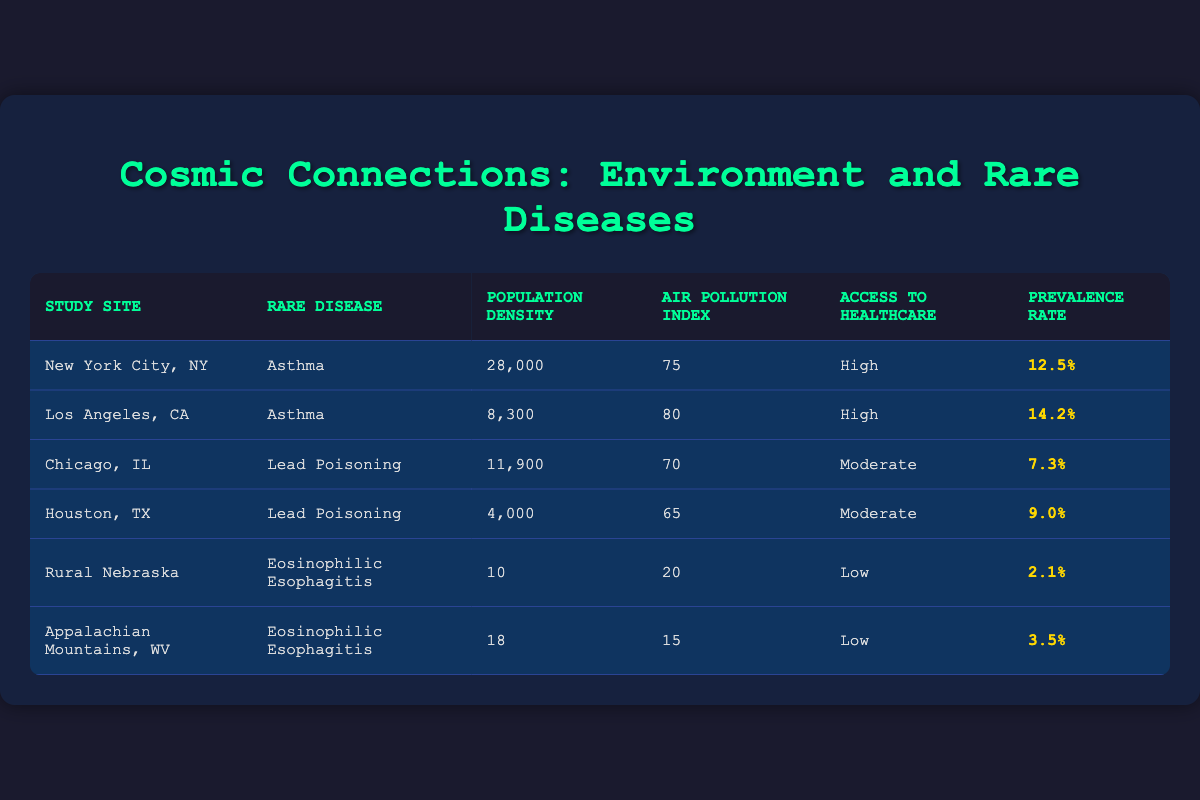What is the prevalence rate of Asthma in New York City, NY? The table shows that the prevalence rate for Asthma in New York City, NY is listed directly as 12.5%.
Answer: 12.5% What is the Air Pollution Index for Los Angeles, CA? According to the table, the Air Pollution Index for Los Angeles, CA is noted as 80.
Answer: 80 Which rare disease has the highest prevalence rate in the urban settings? The prevalence rates for Asthma in New York City (12.5%) and Los Angeles (14.2%) are higher than Lead Poisoning (7.3% in Chicago and 9.0% in Houston). Thus, Asthma in Los Angeles has the highest prevalence rate at 14.2%.
Answer: 14.2% Is the prevalence rate of Eosinophilic Esophagitis in Rural Nebraska higher than in the Appalachian Mountains, WV? The prevalence rate for Eosinophilic Esophagitis in Rural Nebraska is 2.1%, while in the Appalachian Mountains it is 3.5%. Therefore, 2.1% is not higher than 3.5%, making this statement false.
Answer: No What is the average population density for the urban settings listed in the table? The urban population densities are 28,000 (NYC), 8,300 (Los Angeles), 11,900 (Chicago), and 4,000 (Houston). Adding them gives 52,200. Dividing by 4 (the number of urban sites) results in an average of 13,050.
Answer: 13,050 Which study site has the lowest access to healthcare? The table shows that both Rural Nebraska and the Appalachian Mountains have low access to healthcare. Therefore, they both share the lowest status for access.
Answer: Rural Nebraska and Appalachian Mountains If you list the Air Pollution Indexes of Chicago and Houston, which one is lower? In the table, Chicago has an Air Pollution Index of 70, whereas Houston has an index of 65. Since 65 is less than 70, Houston's index is lower.
Answer: Houston What is the total prevalence rate of Lead Poisoning across both urban settings? The prevalence rates for Lead Poisoning in Chicago and Houston are 7.3% and 9.0%, respectively. Adding these rates together gives a total of 16.3%.
Answer: 16.3% Which disease is associated with a higher prevalence rate in urban areas compared to rural areas? Asthma is associated with a prevalence rate of 12.5% in New York City and 14.2% in Los Angeles, whereas Eosinophilic Esophagitis shows 2.1% in Rural Nebraska and 3.5% in Appalachia. Therefore, Asthma is associated with a higher prevalence in urban areas.
Answer: Asthma 